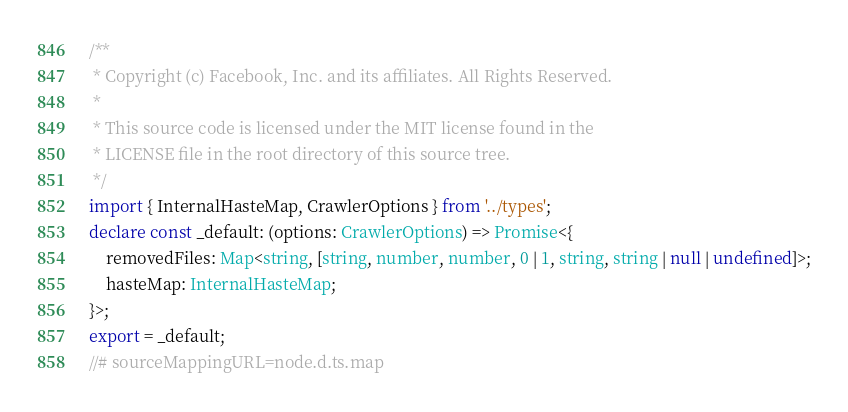Convert code to text. <code><loc_0><loc_0><loc_500><loc_500><_TypeScript_>/**
 * Copyright (c) Facebook, Inc. and its affiliates. All Rights Reserved.
 *
 * This source code is licensed under the MIT license found in the
 * LICENSE file in the root directory of this source tree.
 */
import { InternalHasteMap, CrawlerOptions } from '../types';
declare const _default: (options: CrawlerOptions) => Promise<{
    removedFiles: Map<string, [string, number, number, 0 | 1, string, string | null | undefined]>;
    hasteMap: InternalHasteMap;
}>;
export = _default;
//# sourceMappingURL=node.d.ts.map</code> 